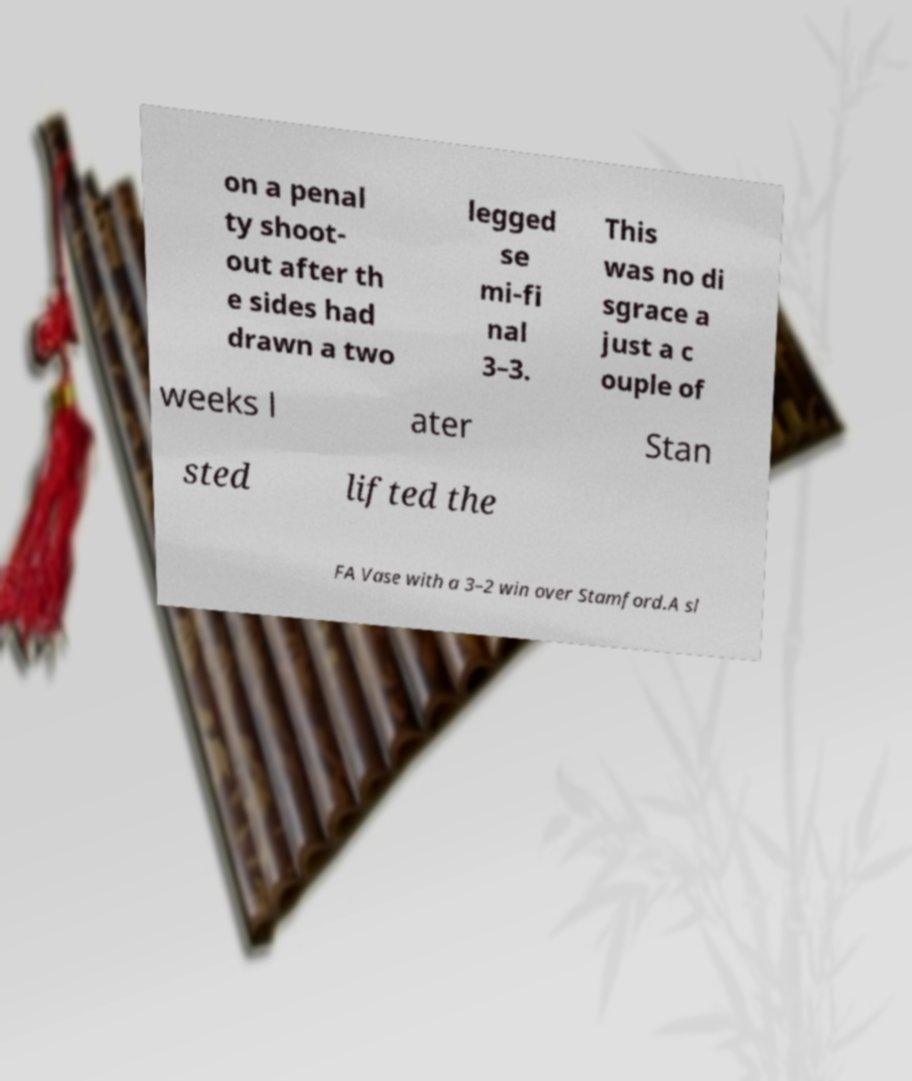Can you accurately transcribe the text from the provided image for me? on a penal ty shoot- out after th e sides had drawn a two legged se mi-fi nal 3–3. This was no di sgrace a just a c ouple of weeks l ater Stan sted lifted the FA Vase with a 3–2 win over Stamford.A sl 